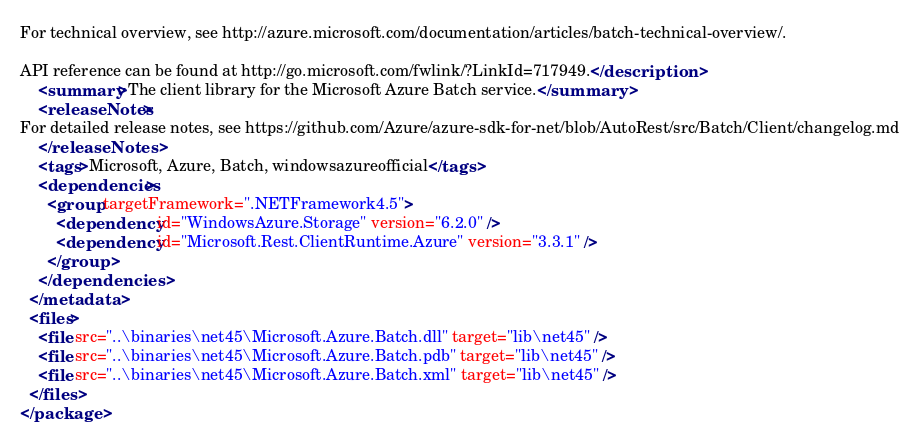Convert code to text. <code><loc_0><loc_0><loc_500><loc_500><_XML_>For technical overview, see http://azure.microsoft.com/documentation/articles/batch-technical-overview/.

API reference can be found at http://go.microsoft.com/fwlink/?LinkId=717949.</description>
    <summary>The client library for the Microsoft Azure Batch service.</summary>
    <releaseNotes>
For detailed release notes, see https://github.com/Azure/azure-sdk-for-net/blob/AutoRest/src/Batch/Client/changelog.md
    </releaseNotes>
    <tags>Microsoft, Azure, Batch, windowsazureofficial</tags>
    <dependencies>
      <group targetFramework=".NETFramework4.5">
        <dependency id="WindowsAzure.Storage" version="6.2.0" />
        <dependency id="Microsoft.Rest.ClientRuntime.Azure" version="3.3.1" />
      </group>
    </dependencies>
  </metadata>
  <files>
    <file src="..\binaries\net45\Microsoft.Azure.Batch.dll" target="lib\net45" />
    <file src="..\binaries\net45\Microsoft.Azure.Batch.pdb" target="lib\net45" />
    <file src="..\binaries\net45\Microsoft.Azure.Batch.xml" target="lib\net45" />
  </files>
</package>
</code> 